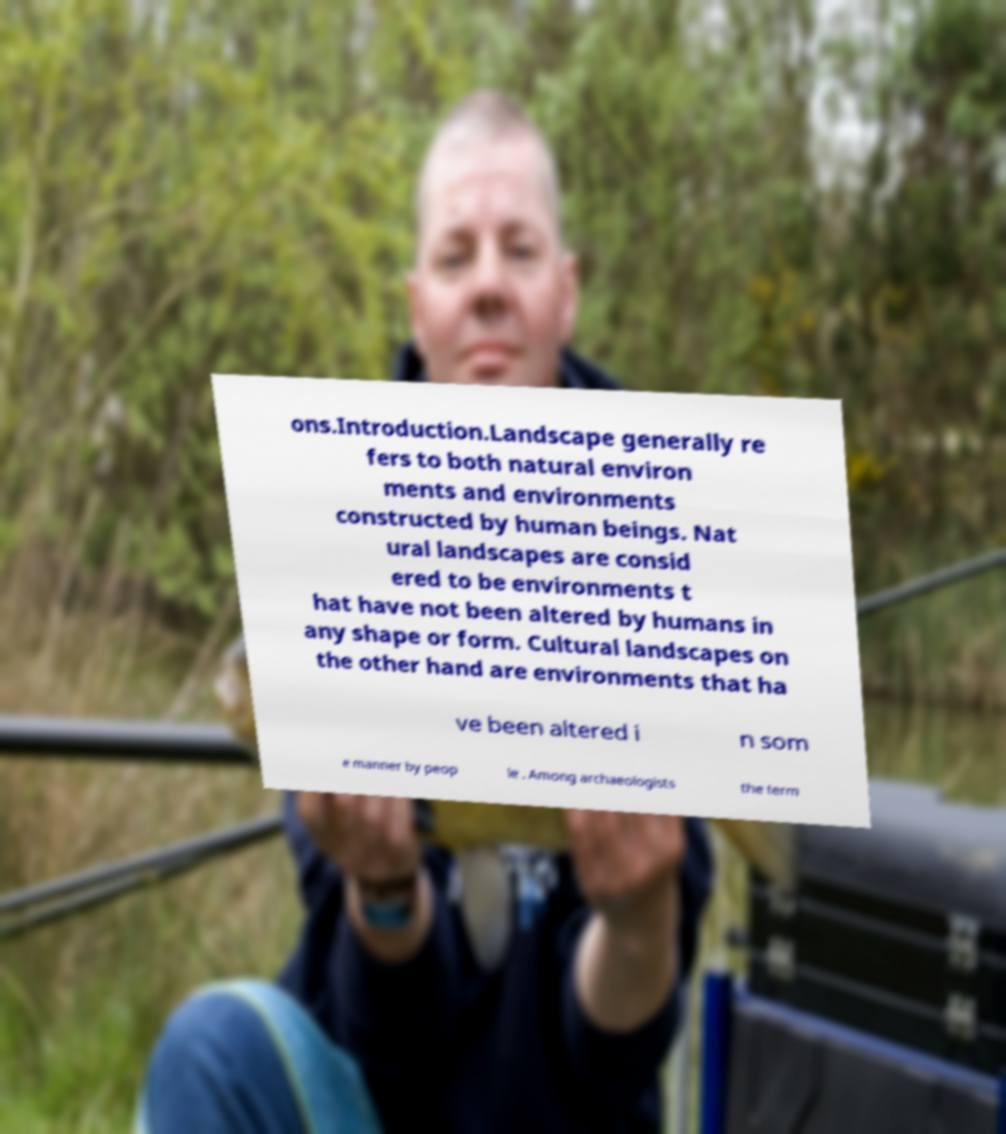There's text embedded in this image that I need extracted. Can you transcribe it verbatim? ons.Introduction.Landscape generally re fers to both natural environ ments and environments constructed by human beings. Nat ural landscapes are consid ered to be environments t hat have not been altered by humans in any shape or form. Cultural landscapes on the other hand are environments that ha ve been altered i n som e manner by peop le . Among archaeologists the term 